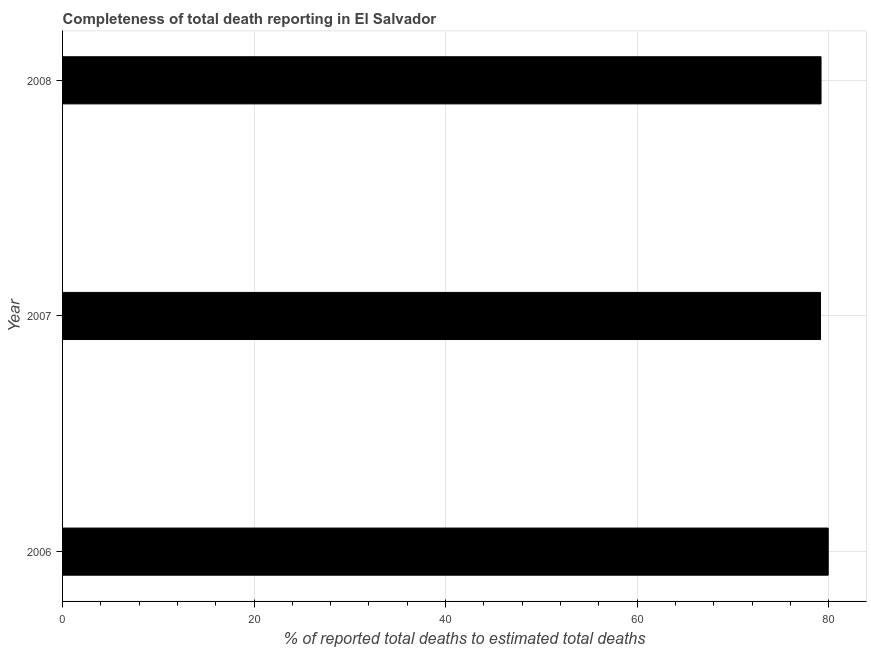What is the title of the graph?
Your response must be concise. Completeness of total death reporting in El Salvador. What is the label or title of the X-axis?
Provide a short and direct response. % of reported total deaths to estimated total deaths. What is the completeness of total death reports in 2008?
Offer a very short reply. 79.21. Across all years, what is the maximum completeness of total death reports?
Ensure brevity in your answer.  79.96. Across all years, what is the minimum completeness of total death reports?
Your response must be concise. 79.15. In which year was the completeness of total death reports minimum?
Keep it short and to the point. 2007. What is the sum of the completeness of total death reports?
Provide a succinct answer. 238.32. What is the difference between the completeness of total death reports in 2006 and 2008?
Offer a very short reply. 0.75. What is the average completeness of total death reports per year?
Your answer should be compact. 79.44. What is the median completeness of total death reports?
Ensure brevity in your answer.  79.21. In how many years, is the completeness of total death reports greater than 76 %?
Make the answer very short. 3. What is the ratio of the completeness of total death reports in 2007 to that in 2008?
Offer a terse response. 1. Is the completeness of total death reports in 2007 less than that in 2008?
Make the answer very short. Yes. Is the difference between the completeness of total death reports in 2006 and 2008 greater than the difference between any two years?
Offer a terse response. No. What is the difference between the highest and the second highest completeness of total death reports?
Make the answer very short. 0.75. Is the sum of the completeness of total death reports in 2007 and 2008 greater than the maximum completeness of total death reports across all years?
Offer a terse response. Yes. What is the difference between the highest and the lowest completeness of total death reports?
Offer a very short reply. 0.81. Are all the bars in the graph horizontal?
Your response must be concise. Yes. How many years are there in the graph?
Provide a succinct answer. 3. What is the % of reported total deaths to estimated total deaths in 2006?
Ensure brevity in your answer.  79.96. What is the % of reported total deaths to estimated total deaths of 2007?
Your response must be concise. 79.15. What is the % of reported total deaths to estimated total deaths of 2008?
Offer a terse response. 79.21. What is the difference between the % of reported total deaths to estimated total deaths in 2006 and 2007?
Your response must be concise. 0.81. What is the difference between the % of reported total deaths to estimated total deaths in 2006 and 2008?
Provide a succinct answer. 0.75. What is the difference between the % of reported total deaths to estimated total deaths in 2007 and 2008?
Keep it short and to the point. -0.06. What is the ratio of the % of reported total deaths to estimated total deaths in 2006 to that in 2008?
Your answer should be very brief. 1.01. What is the ratio of the % of reported total deaths to estimated total deaths in 2007 to that in 2008?
Your answer should be very brief. 1. 